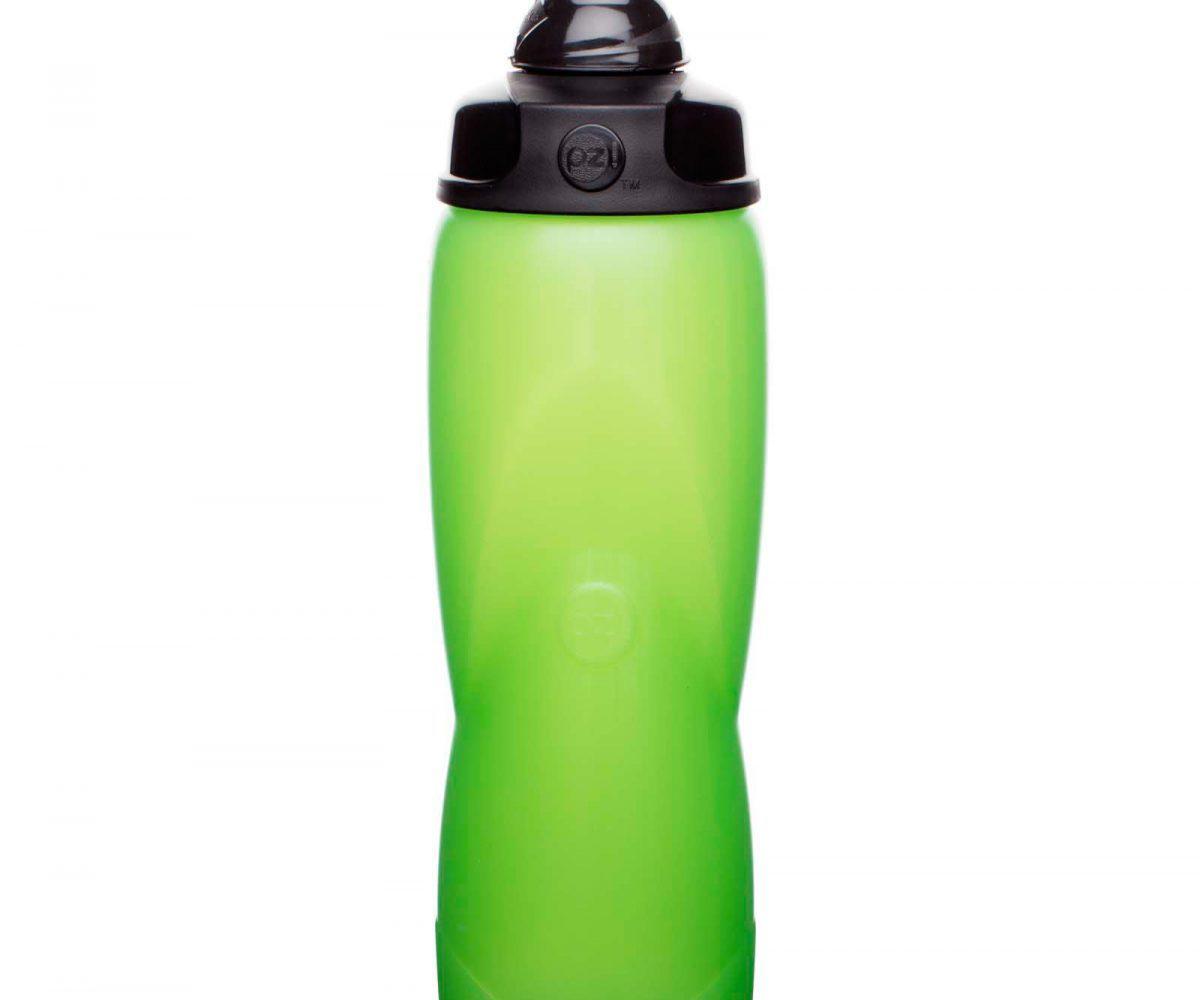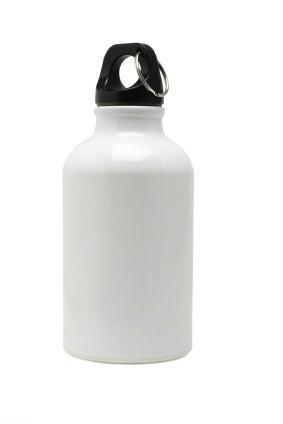The first image is the image on the left, the second image is the image on the right. For the images displayed, is the sentence "At least one wide blue tinted bottle with a plastic cap is shown in one image, while a second image shows a personal water bottle with detachable cap." factually correct? Answer yes or no. No. The first image is the image on the left, the second image is the image on the right. Analyze the images presented: Is the assertion "An image shows at least one stout translucent blue water jug with a lid on it." valid? Answer yes or no. No. 